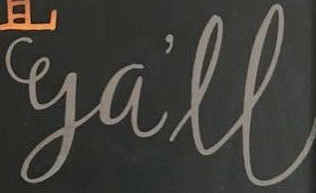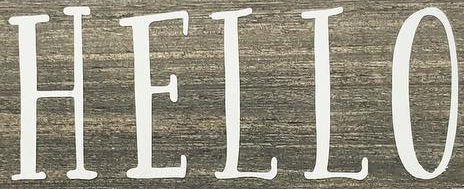Identify the words shown in these images in order, separated by a semicolon. ga'll; HELLO 